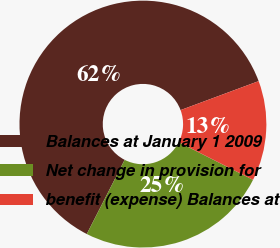<chart> <loc_0><loc_0><loc_500><loc_500><pie_chart><fcel>Balances at January 1 2009<fcel>Net change in provision for<fcel>benefit (expense) Balances at<nl><fcel>61.83%<fcel>25.05%<fcel>13.12%<nl></chart> 